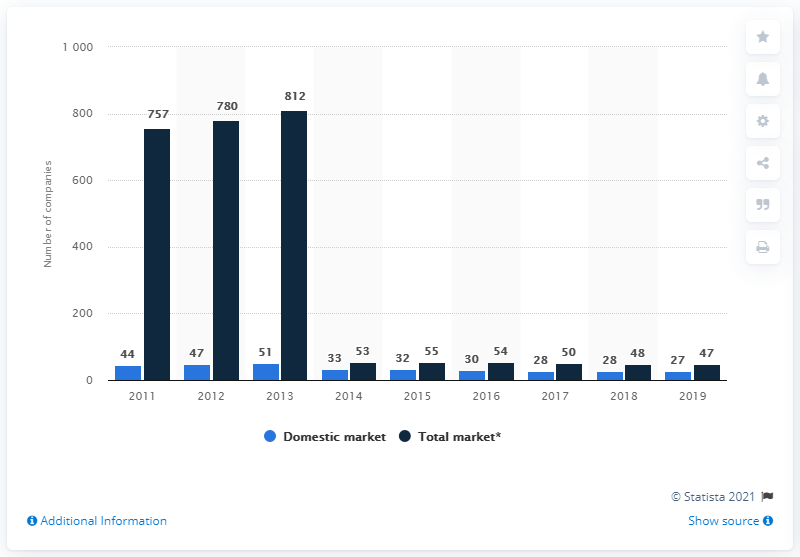Draw attention to some important aspects in this diagram. In 2019, there were 27 operational insurance companies on the domestic market. 